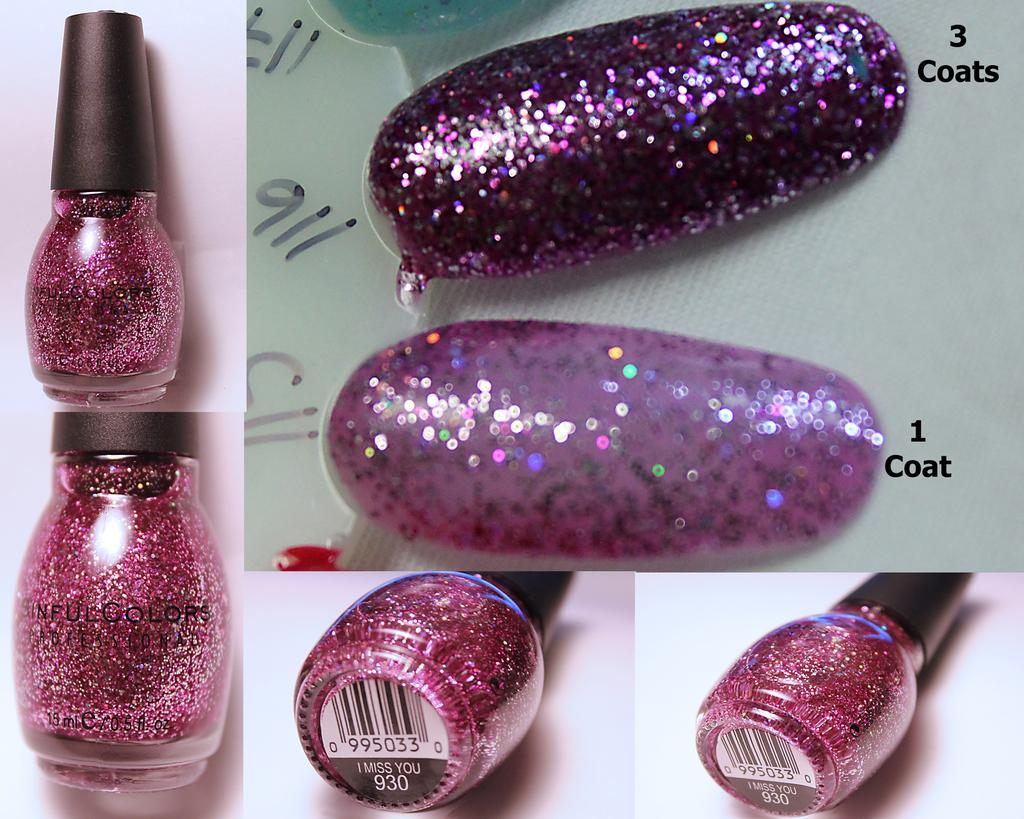What is the composition of the image? The image is a collage of different pictures. What can be seen in some of the pictures within the collage? There are nail polish bottles in some of the pictures. What is applied to objects in some of the pictures? There is coating on objects in some of the pictures. What is the rate of gold production in the image? There is no mention of gold production or any related information in the image. 